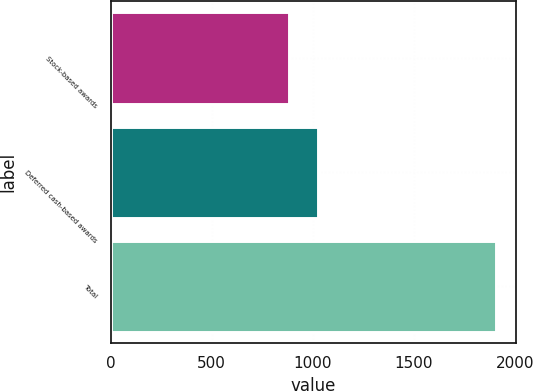<chart> <loc_0><loc_0><loc_500><loc_500><bar_chart><fcel>Stock-based awards<fcel>Deferred cash-based awards<fcel>Total<nl><fcel>882<fcel>1027<fcel>1909<nl></chart> 